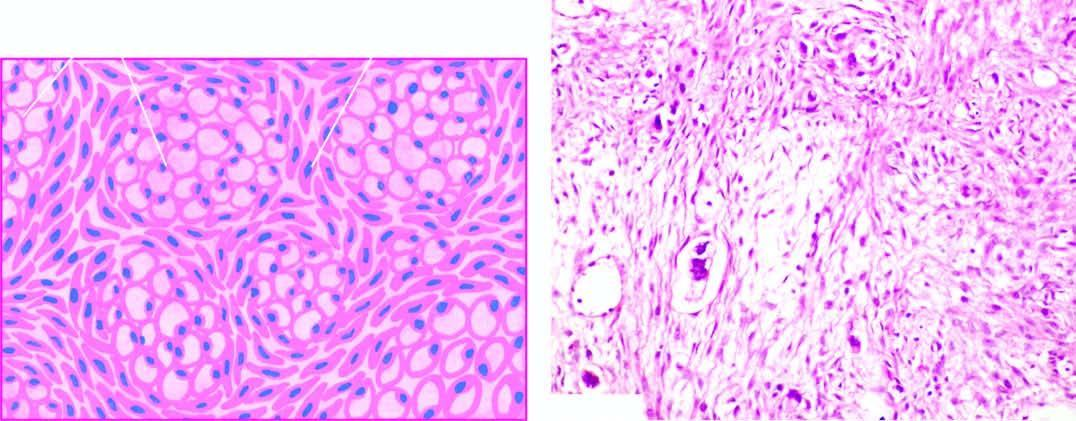do histologic features include mucin-filled signet-ring cells and richly cellular proliferation of the ovarian stroma?
Answer the question using a single word or phrase. Yes 